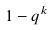<formula> <loc_0><loc_0><loc_500><loc_500>1 - q ^ { k }</formula> 